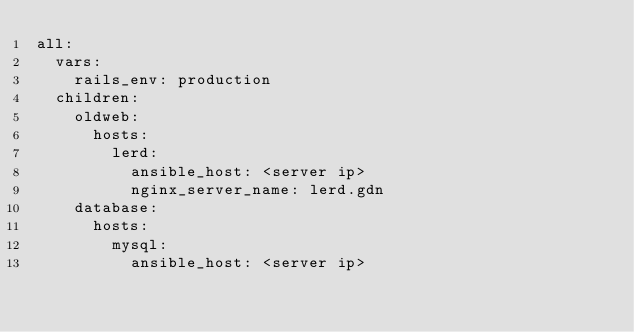Convert code to text. <code><loc_0><loc_0><loc_500><loc_500><_YAML_>all:
  vars:
    rails_env: production
  children:
    oldweb:
      hosts:
        lerd:
          ansible_host: <server ip>
          nginx_server_name: lerd.gdn
    database:
      hosts:
        mysql:
          ansible_host: <server ip>
</code> 